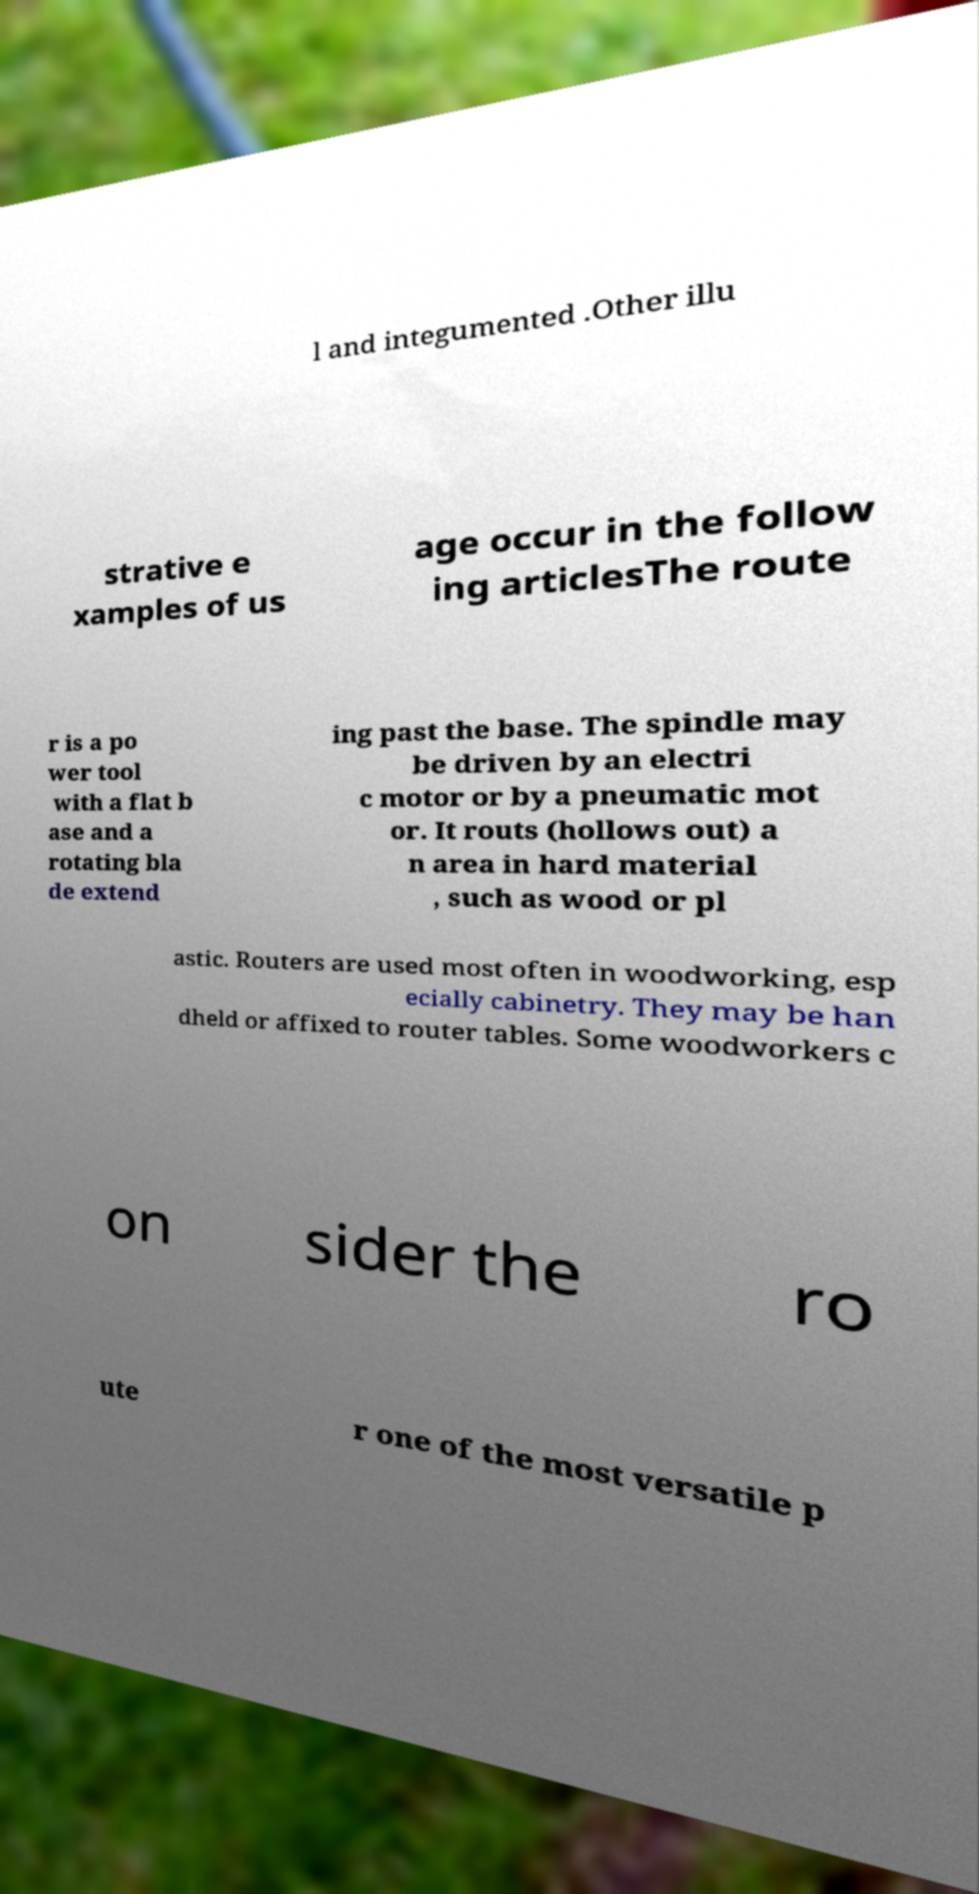Can you accurately transcribe the text from the provided image for me? l and integumented .Other illu strative e xamples of us age occur in the follow ing articlesThe route r is a po wer tool with a flat b ase and a rotating bla de extend ing past the base. The spindle may be driven by an electri c motor or by a pneumatic mot or. It routs (hollows out) a n area in hard material , such as wood or pl astic. Routers are used most often in woodworking, esp ecially cabinetry. They may be han dheld or affixed to router tables. Some woodworkers c on sider the ro ute r one of the most versatile p 